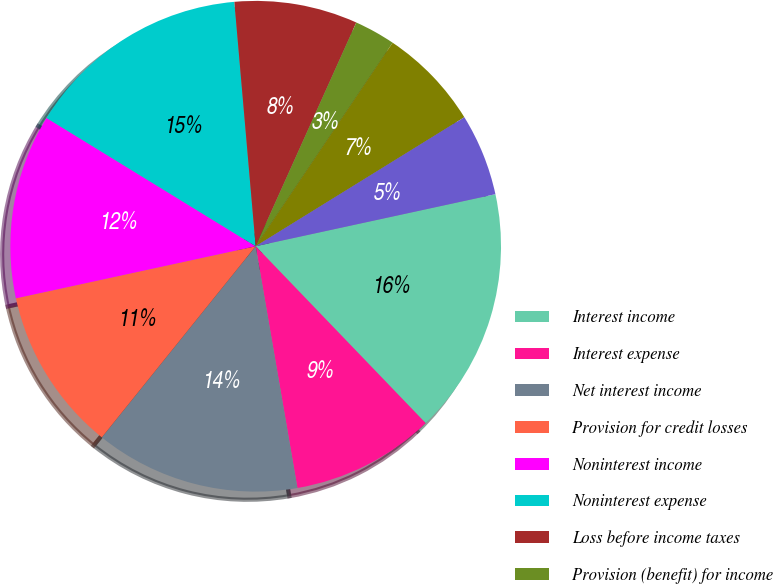<chart> <loc_0><loc_0><loc_500><loc_500><pie_chart><fcel>Interest income<fcel>Interest expense<fcel>Net interest income<fcel>Provision for credit losses<fcel>Noninterest income<fcel>Noninterest expense<fcel>Loss before income taxes<fcel>Provision (benefit) for income<fcel>Net income<fcel>Dividends declared on<nl><fcel>16.22%<fcel>9.46%<fcel>13.51%<fcel>10.81%<fcel>12.16%<fcel>14.86%<fcel>8.11%<fcel>2.7%<fcel>6.76%<fcel>5.41%<nl></chart> 